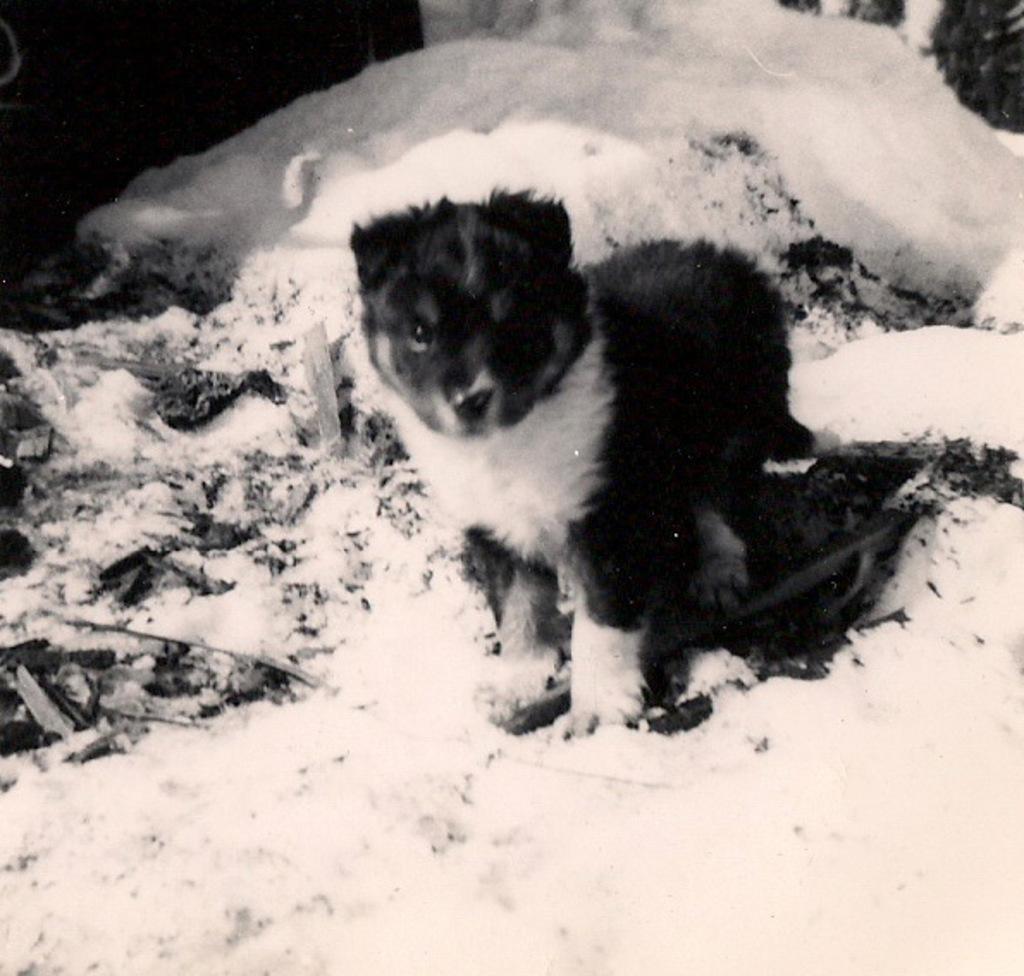Describe this image in one or two sentences. In this picture there is a puppy who is standing on the snow, beside him I can see the sleeper and some sticks. 